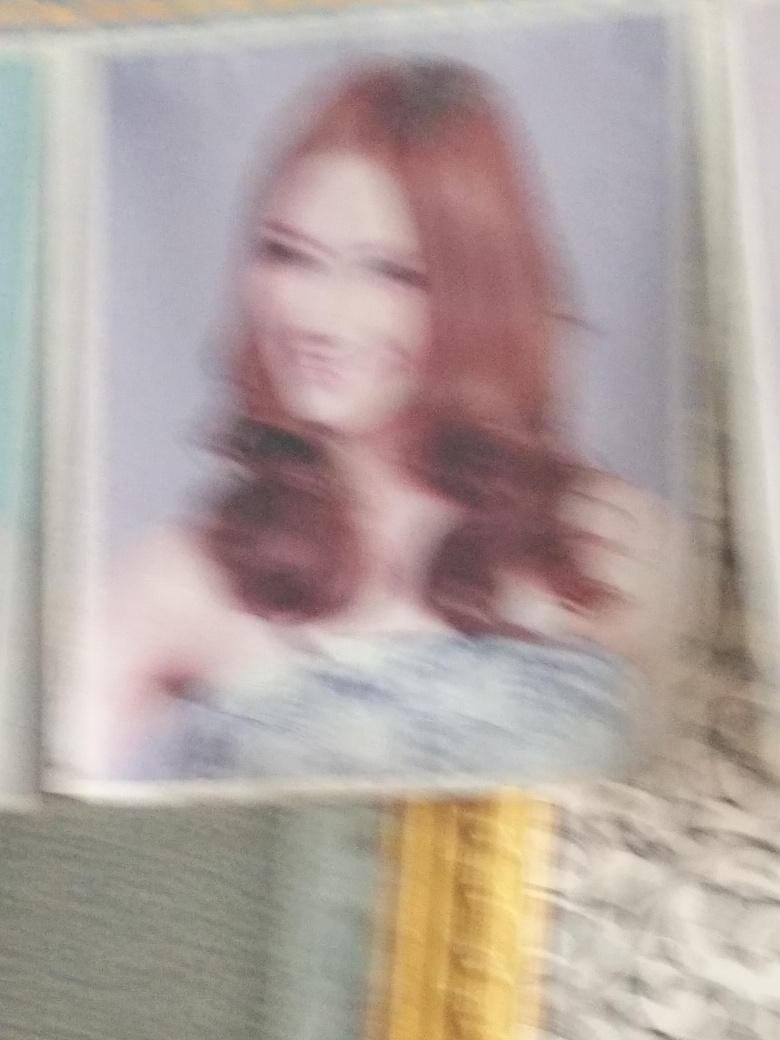Describe the colors visible in this image despite the blurriness. Despite the blurred quality of the image, it's possible to discern a combination of warm tones that suggest an array of colors such as soft reds or pinks, possibly from the subject's hair, and some cooler tones that may originate from the background or attire. The exact hues are difficult to determine due to the lack of sharpness. 